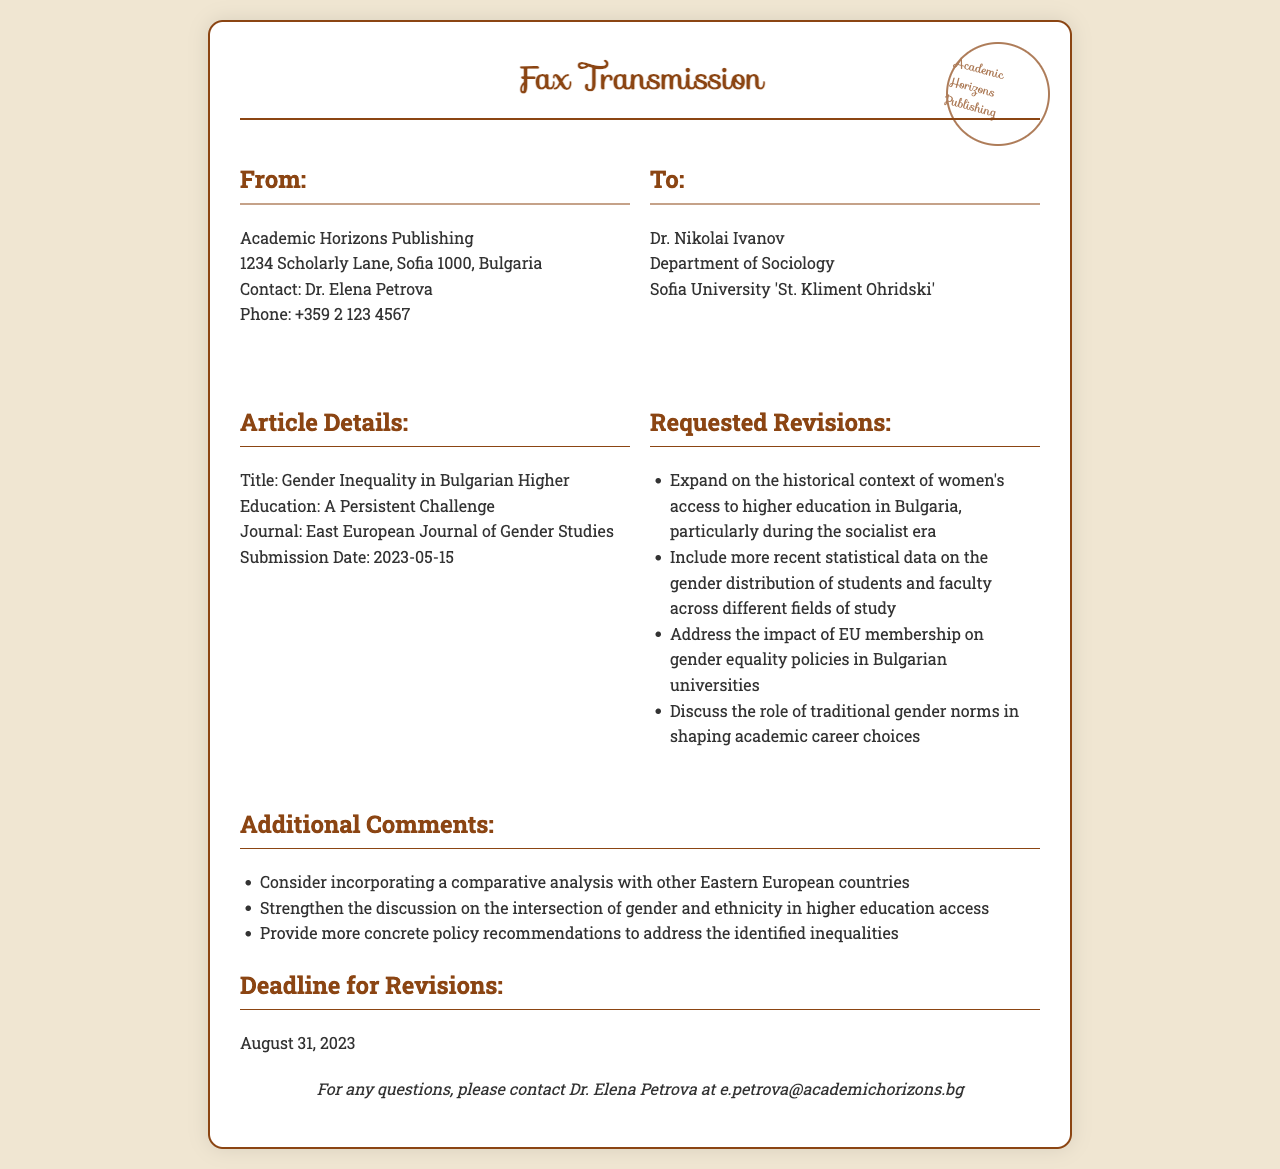What is the title of the article? The title of the article can be found in the article details section of the fax, which is "Gender Inequality in Bulgarian Higher Education: A Persistent Challenge."
Answer: Gender Inequality in Bulgarian Higher Education: A Persistent Challenge Who is the contact person for the publisher? The contact person for the publisher is indicated in the sender's information section, where it states "Dr. Elena Petrova."
Answer: Dr. Elena Petrova What is the submission date of the article? The submission date is provided in the article details section of the fax as "2023-05-15."
Answer: 2023-05-15 What is the deadline for revisions? The deadline for revisions is clearly mentioned in the document, which states "August 31, 2023."
Answer: August 31, 2023 Which journal is the article submitted to? The journal name is listed in the article details section as "East European Journal of Gender Studies."
Answer: East European Journal of Gender Studies What are requested revisions related to historical context? One of the requested revisions involves expanding on the historical context of women's access to higher education in Bulgaria, specifically during the socialist era.
Answer: Historical context of women's access to higher education What additional comments suggest comparative analysis? One of the additional comments suggests considering incorporating a comparative analysis with other Eastern European countries.
Answer: Comparative analysis with other Eastern European countries How many requested revisions are listed? The document outlines four requested revisions regarding the article, indicating a specific number.
Answer: Four What is the phone number of the publisher? The phone number of the publisher is provided in the sender's information as "+359 2 123 4567."
Answer: +359 2 123 4567 